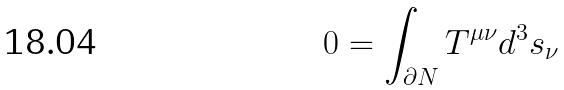<formula> <loc_0><loc_0><loc_500><loc_500>0 = \int _ { \partial N } T ^ { \mu \nu } d ^ { 3 } s _ { \nu }</formula> 